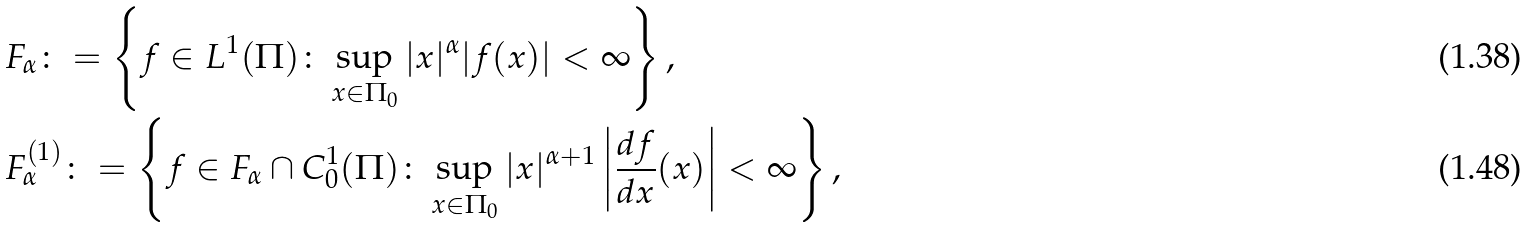Convert formula to latex. <formula><loc_0><loc_0><loc_500><loc_500>& F _ { \alpha } \colon = \left \{ f \in L ^ { 1 } ( \Pi ) \colon \sup _ { x \in \Pi _ { 0 } } | x | ^ { \alpha } | f ( x ) | < \infty \right \} , \\ & F _ { \alpha } ^ { ( 1 ) } \colon = \left \{ f \in F _ { \alpha } \cap C ^ { 1 } _ { 0 } ( \Pi ) \colon \sup _ { x \in \Pi _ { 0 } } | x | ^ { \alpha + 1 } \left | \frac { d f } { d x } ( x ) \right | < \infty \right \} ,</formula> 